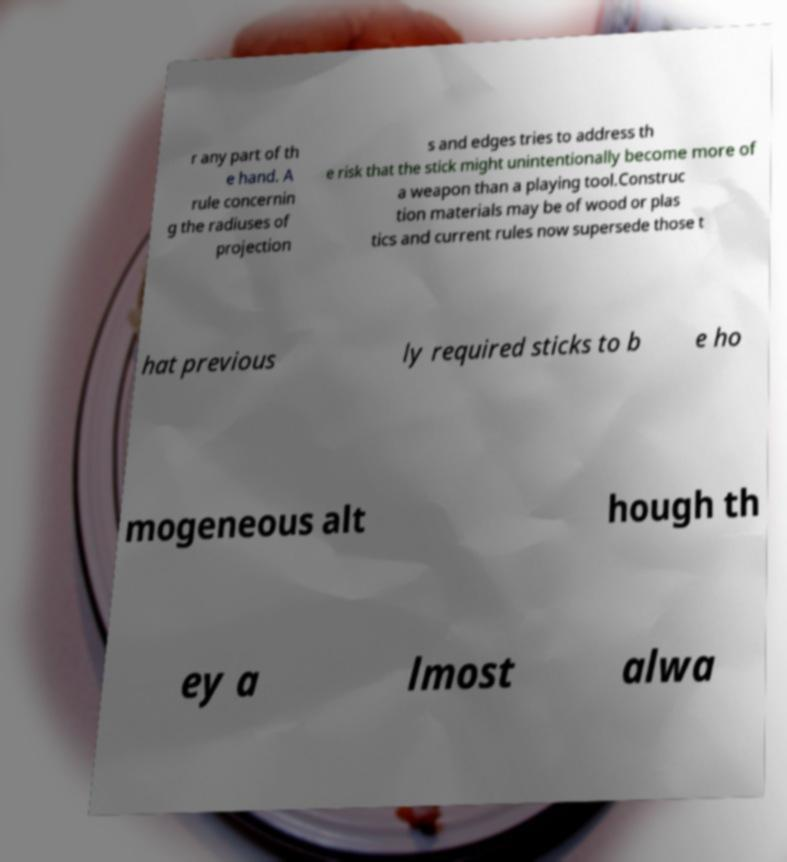I need the written content from this picture converted into text. Can you do that? r any part of th e hand. A rule concernin g the radiuses of projection s and edges tries to address th e risk that the stick might unintentionally become more of a weapon than a playing tool.Construc tion materials may be of wood or plas tics and current rules now supersede those t hat previous ly required sticks to b e ho mogeneous alt hough th ey a lmost alwa 